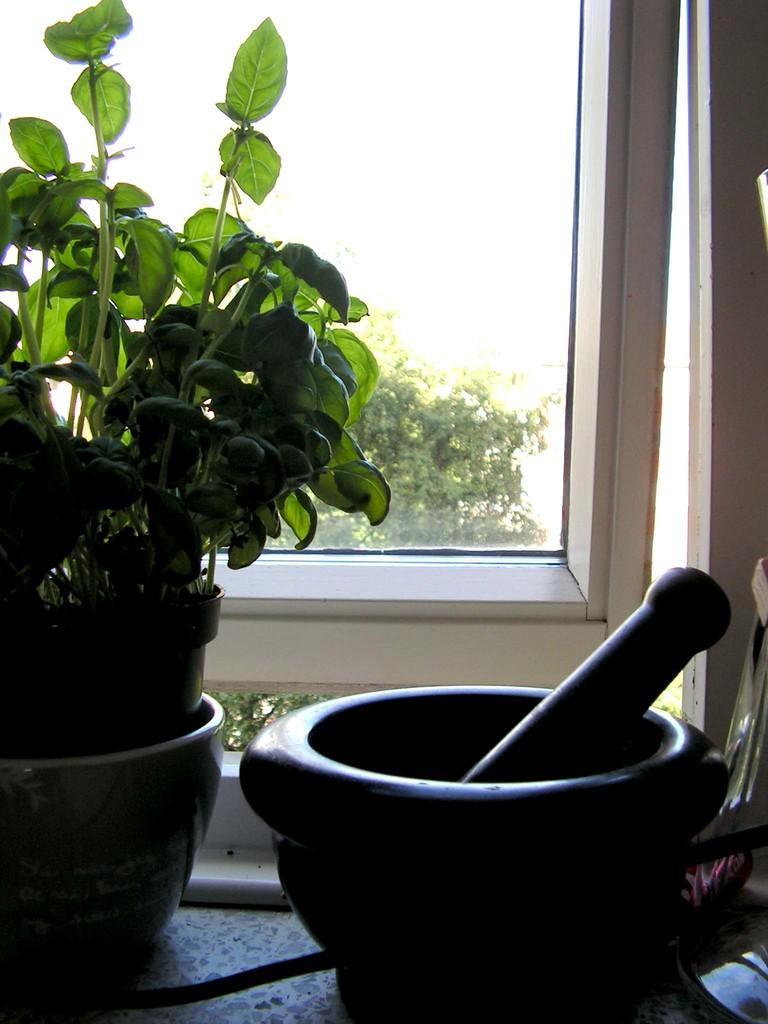What type of plant can be seen in the image? There is a potted plant in the image. What architectural feature is present in the image? There is a window in the image. What object is used for grinding in the image? There is a grinding stone in the image. What can be seen through the window in the image? Trees and the sky are visible through the window. How many flowers are being used by the spy in the image? There are no flowers or spies present in the image. What type of rock is being used by the spy in the image? There are no rocks or spies present in the image. 